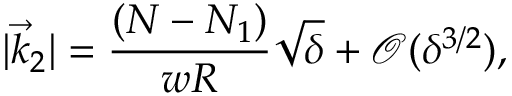Convert formula to latex. <formula><loc_0><loc_0><loc_500><loc_500>| \vec { k } _ { 2 } | = { \frac { ( N - N _ { 1 } ) } { w R } } \sqrt { \delta } + { \mathcal { O } } ( \delta ^ { 3 / 2 } ) ,</formula> 